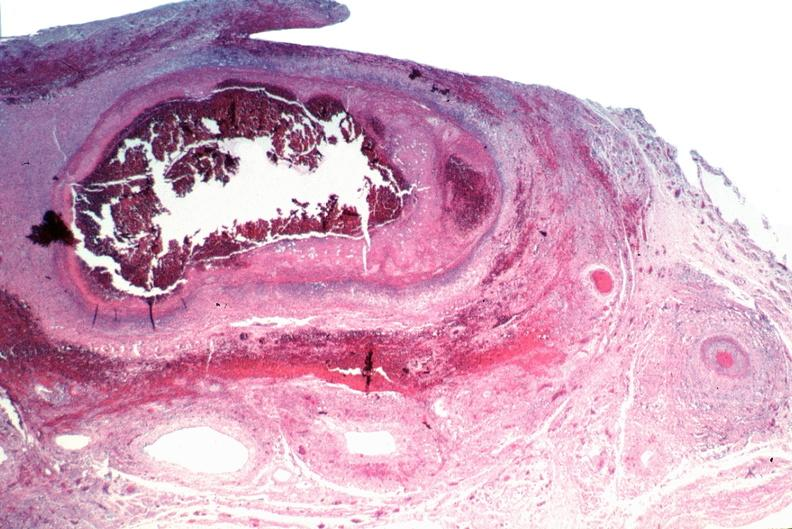s amyloidosis present?
Answer the question using a single word or phrase. No 